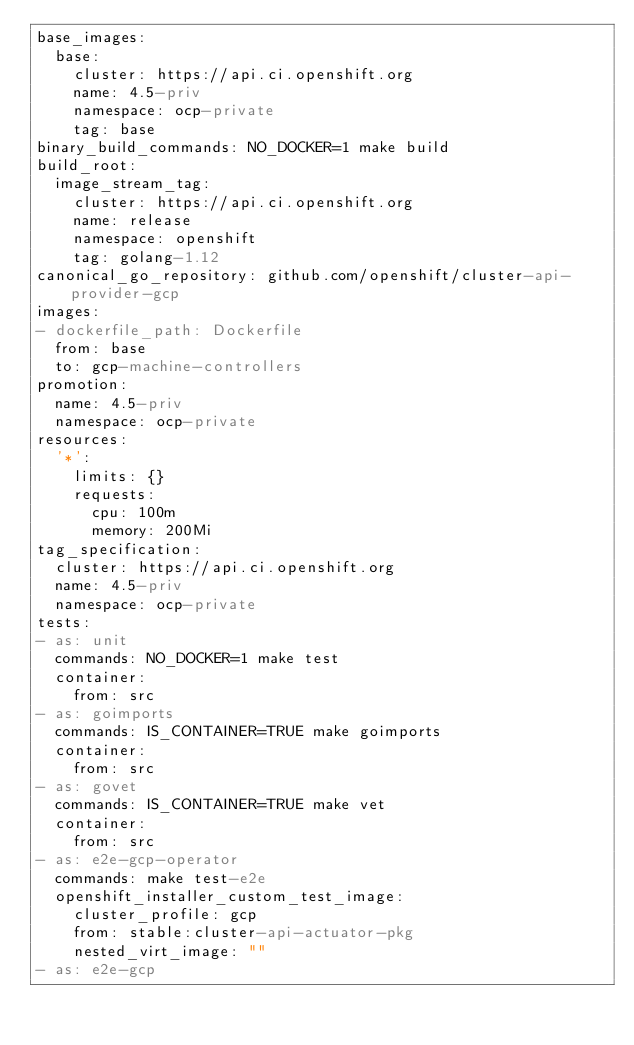<code> <loc_0><loc_0><loc_500><loc_500><_YAML_>base_images:
  base:
    cluster: https://api.ci.openshift.org
    name: 4.5-priv
    namespace: ocp-private
    tag: base
binary_build_commands: NO_DOCKER=1 make build
build_root:
  image_stream_tag:
    cluster: https://api.ci.openshift.org
    name: release
    namespace: openshift
    tag: golang-1.12
canonical_go_repository: github.com/openshift/cluster-api-provider-gcp
images:
- dockerfile_path: Dockerfile
  from: base
  to: gcp-machine-controllers
promotion:
  name: 4.5-priv
  namespace: ocp-private
resources:
  '*':
    limits: {}
    requests:
      cpu: 100m
      memory: 200Mi
tag_specification:
  cluster: https://api.ci.openshift.org
  name: 4.5-priv
  namespace: ocp-private
tests:
- as: unit
  commands: NO_DOCKER=1 make test
  container:
    from: src
- as: goimports
  commands: IS_CONTAINER=TRUE make goimports
  container:
    from: src
- as: govet
  commands: IS_CONTAINER=TRUE make vet
  container:
    from: src
- as: e2e-gcp-operator
  commands: make test-e2e
  openshift_installer_custom_test_image:
    cluster_profile: gcp
    from: stable:cluster-api-actuator-pkg
    nested_virt_image: ""
- as: e2e-gcp</code> 